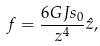Convert formula to latex. <formula><loc_0><loc_0><loc_500><loc_500>f = \frac { 6 G J s _ { 0 } } { z ^ { 4 } } \hat { z } ,</formula> 